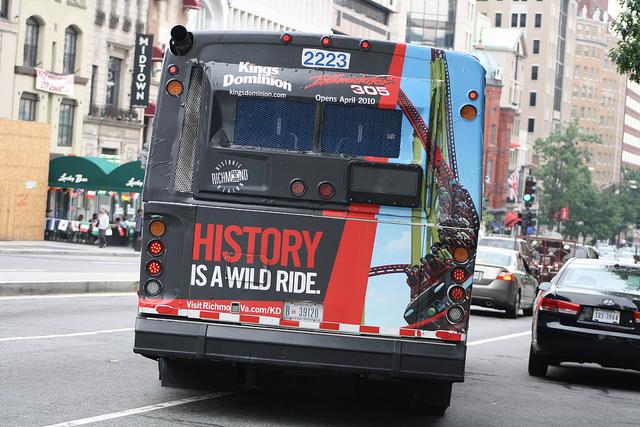What numbers is on the bus?
Write a very short answer. 2223. What is the brand of the car?
Answer briefly. Honda. What kind of ride is history?
Concise answer only. Wild. What color is the car right in front of the picture?
Short answer required. Black. Is the road clear?
Write a very short answer. No. 